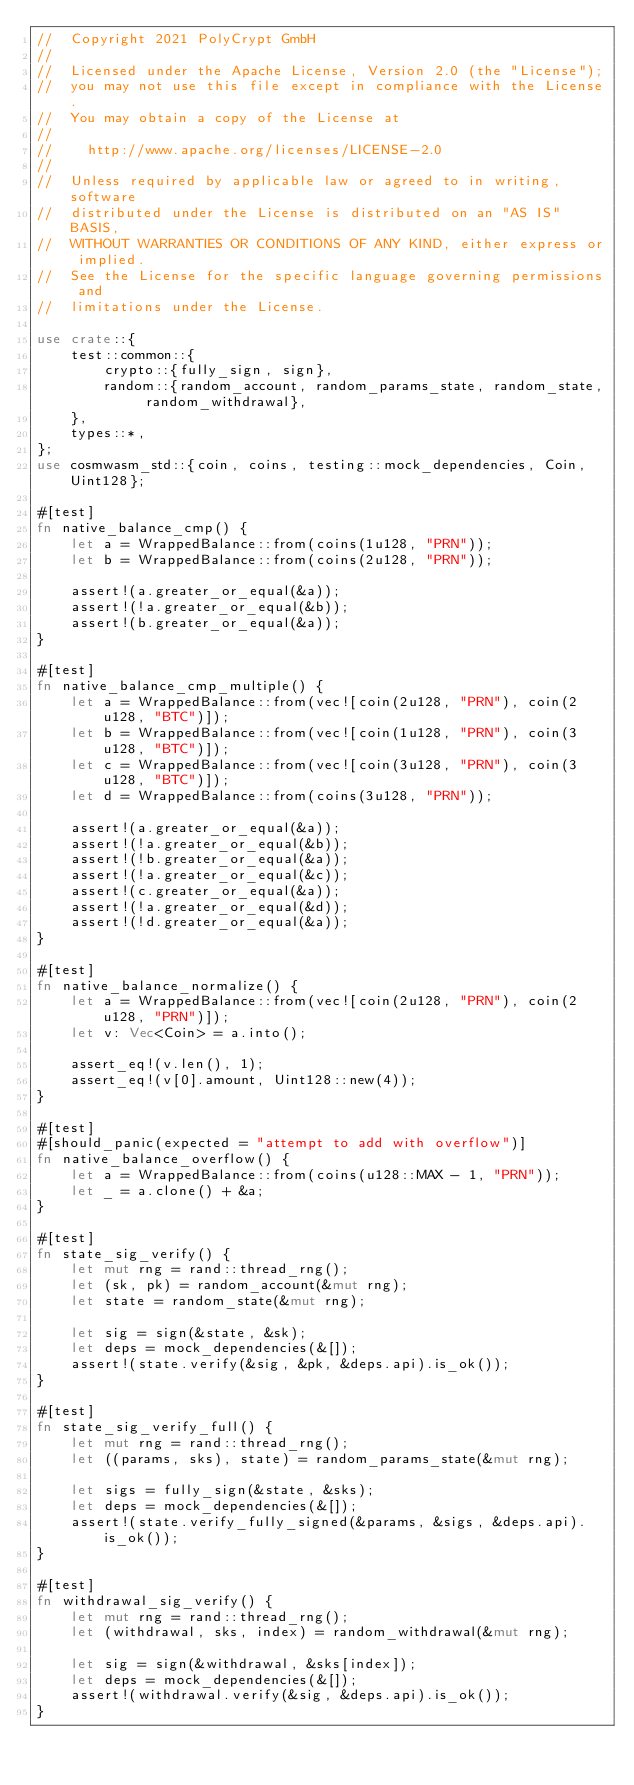Convert code to text. <code><loc_0><loc_0><loc_500><loc_500><_Rust_>//  Copyright 2021 PolyCrypt GmbH
//
//  Licensed under the Apache License, Version 2.0 (the "License");
//  you may not use this file except in compliance with the License.
//  You may obtain a copy of the License at
//
//    http://www.apache.org/licenses/LICENSE-2.0
//
//  Unless required by applicable law or agreed to in writing, software
//  distributed under the License is distributed on an "AS IS" BASIS,
//  WITHOUT WARRANTIES OR CONDITIONS OF ANY KIND, either express or implied.
//  See the License for the specific language governing permissions and
//  limitations under the License.

use crate::{
    test::common::{
        crypto::{fully_sign, sign},
        random::{random_account, random_params_state, random_state, random_withdrawal},
    },
    types::*,
};
use cosmwasm_std::{coin, coins, testing::mock_dependencies, Coin, Uint128};

#[test]
fn native_balance_cmp() {
    let a = WrappedBalance::from(coins(1u128, "PRN"));
    let b = WrappedBalance::from(coins(2u128, "PRN"));

    assert!(a.greater_or_equal(&a));
    assert!(!a.greater_or_equal(&b));
    assert!(b.greater_or_equal(&a));
}

#[test]
fn native_balance_cmp_multiple() {
    let a = WrappedBalance::from(vec![coin(2u128, "PRN"), coin(2u128, "BTC")]);
    let b = WrappedBalance::from(vec![coin(1u128, "PRN"), coin(3u128, "BTC")]);
    let c = WrappedBalance::from(vec![coin(3u128, "PRN"), coin(3u128, "BTC")]);
    let d = WrappedBalance::from(coins(3u128, "PRN"));

    assert!(a.greater_or_equal(&a));
    assert!(!a.greater_or_equal(&b));
    assert!(!b.greater_or_equal(&a));
    assert!(!a.greater_or_equal(&c));
    assert!(c.greater_or_equal(&a));
    assert!(!a.greater_or_equal(&d));
    assert!(!d.greater_or_equal(&a));
}

#[test]
fn native_balance_normalize() {
    let a = WrappedBalance::from(vec![coin(2u128, "PRN"), coin(2u128, "PRN")]);
    let v: Vec<Coin> = a.into();

    assert_eq!(v.len(), 1);
    assert_eq!(v[0].amount, Uint128::new(4));
}

#[test]
#[should_panic(expected = "attempt to add with overflow")]
fn native_balance_overflow() {
    let a = WrappedBalance::from(coins(u128::MAX - 1, "PRN"));
    let _ = a.clone() + &a;
}

#[test]
fn state_sig_verify() {
    let mut rng = rand::thread_rng();
    let (sk, pk) = random_account(&mut rng);
    let state = random_state(&mut rng);

    let sig = sign(&state, &sk);
    let deps = mock_dependencies(&[]);
    assert!(state.verify(&sig, &pk, &deps.api).is_ok());
}

#[test]
fn state_sig_verify_full() {
    let mut rng = rand::thread_rng();
    let ((params, sks), state) = random_params_state(&mut rng);

    let sigs = fully_sign(&state, &sks);
    let deps = mock_dependencies(&[]);
    assert!(state.verify_fully_signed(&params, &sigs, &deps.api).is_ok());
}

#[test]
fn withdrawal_sig_verify() {
    let mut rng = rand::thread_rng();
    let (withdrawal, sks, index) = random_withdrawal(&mut rng);

    let sig = sign(&withdrawal, &sks[index]);
    let deps = mock_dependencies(&[]);
    assert!(withdrawal.verify(&sig, &deps.api).is_ok());
}
</code> 